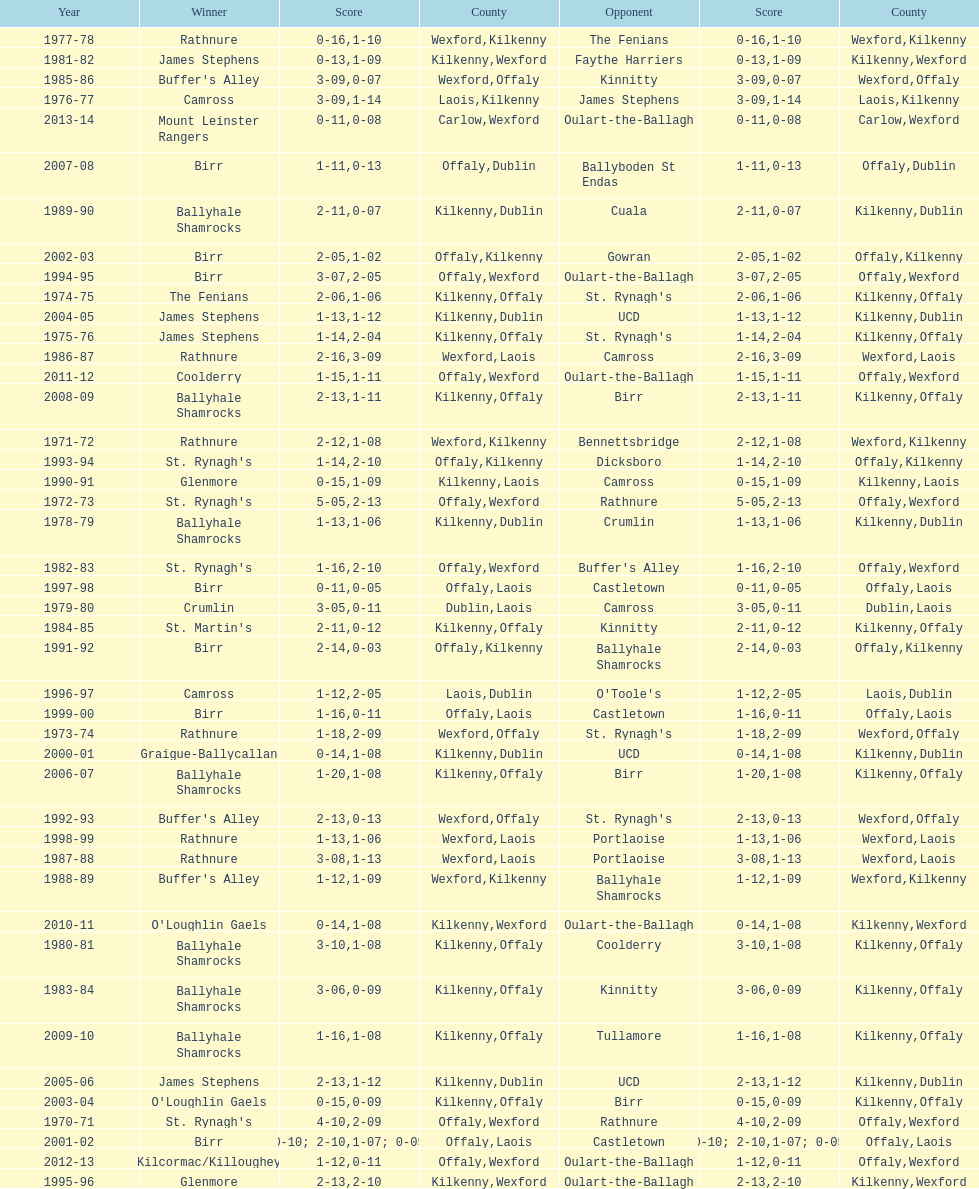Which winner is next to mount leinster rangers? Kilcormac/Killoughey. 